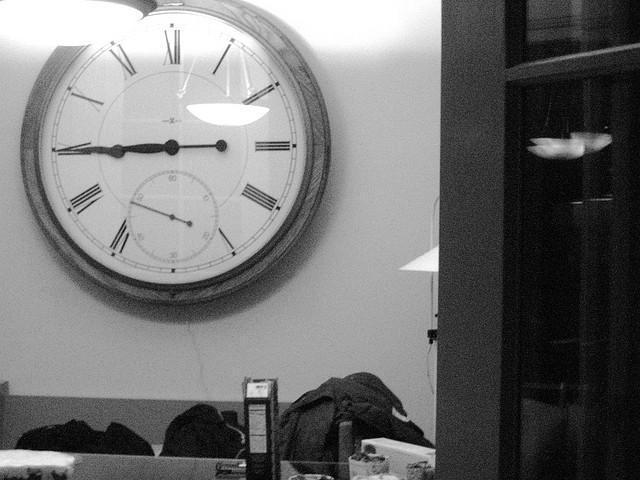How many clocks on the wall?
Give a very brief answer. 1. 